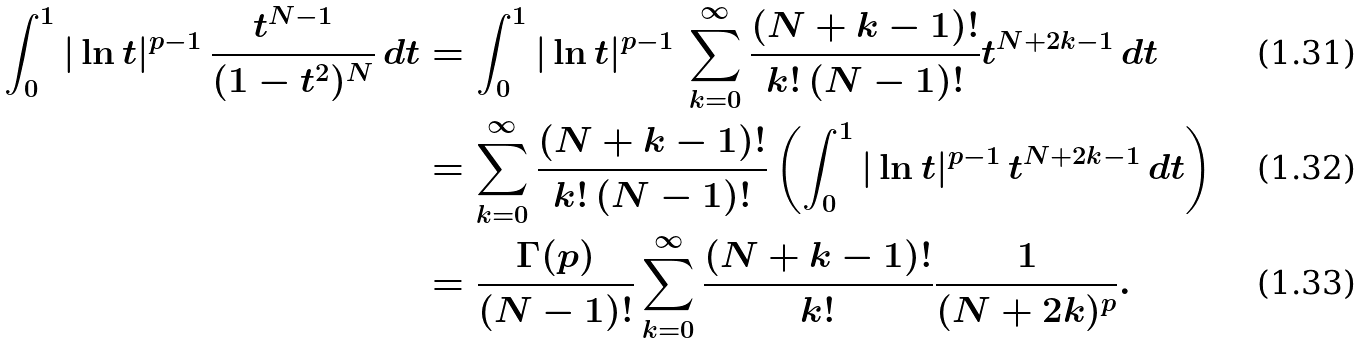<formula> <loc_0><loc_0><loc_500><loc_500>\int _ { 0 } ^ { 1 } | \ln { t } | ^ { p - 1 } \, \frac { t ^ { N - 1 } } { ( 1 - t ^ { 2 } ) ^ { N } } \, d t & = \int _ { 0 } ^ { 1 } | \ln { t } | ^ { p - 1 } \, \sum _ { k = 0 } ^ { \infty } \frac { ( N + k - 1 ) ! } { k ! \, ( N - 1 ) ! } t ^ { N + 2 k - 1 } \, d t \\ & = \sum _ { k = 0 } ^ { \infty } \frac { ( N + k - 1 ) ! } { k ! \, ( N - 1 ) ! } \left ( \int _ { 0 } ^ { 1 } | \ln { t } | ^ { p - 1 } \, t ^ { N + 2 k - 1 } \, d t \right ) \\ & = \frac { \Gamma ( p ) } { ( N - 1 ) ! } \sum _ { k = 0 } ^ { \infty } \frac { ( N + k - 1 ) ! } { k ! } \frac { 1 } { ( N + 2 k ) ^ { p } } .</formula> 